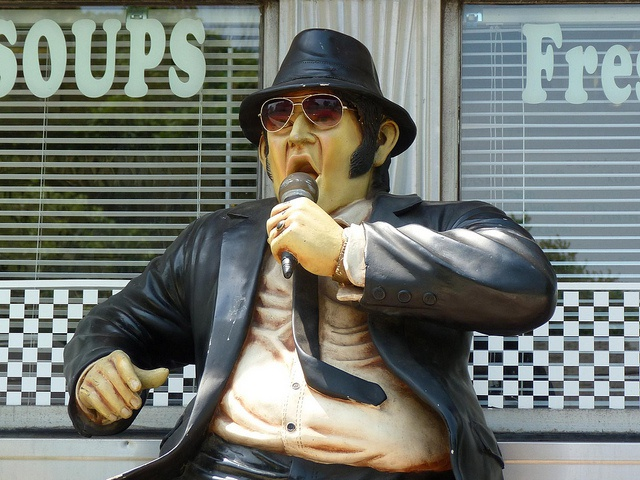Describe the objects in this image and their specific colors. I can see people in black, gray, ivory, and darkgray tones and tie in black, gray, and darkblue tones in this image. 